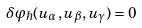<formula> <loc_0><loc_0><loc_500><loc_500>\delta \varphi _ { \hbar } ( u _ { \alpha } , u _ { \beta } , u _ { \gamma } ) = 0</formula> 